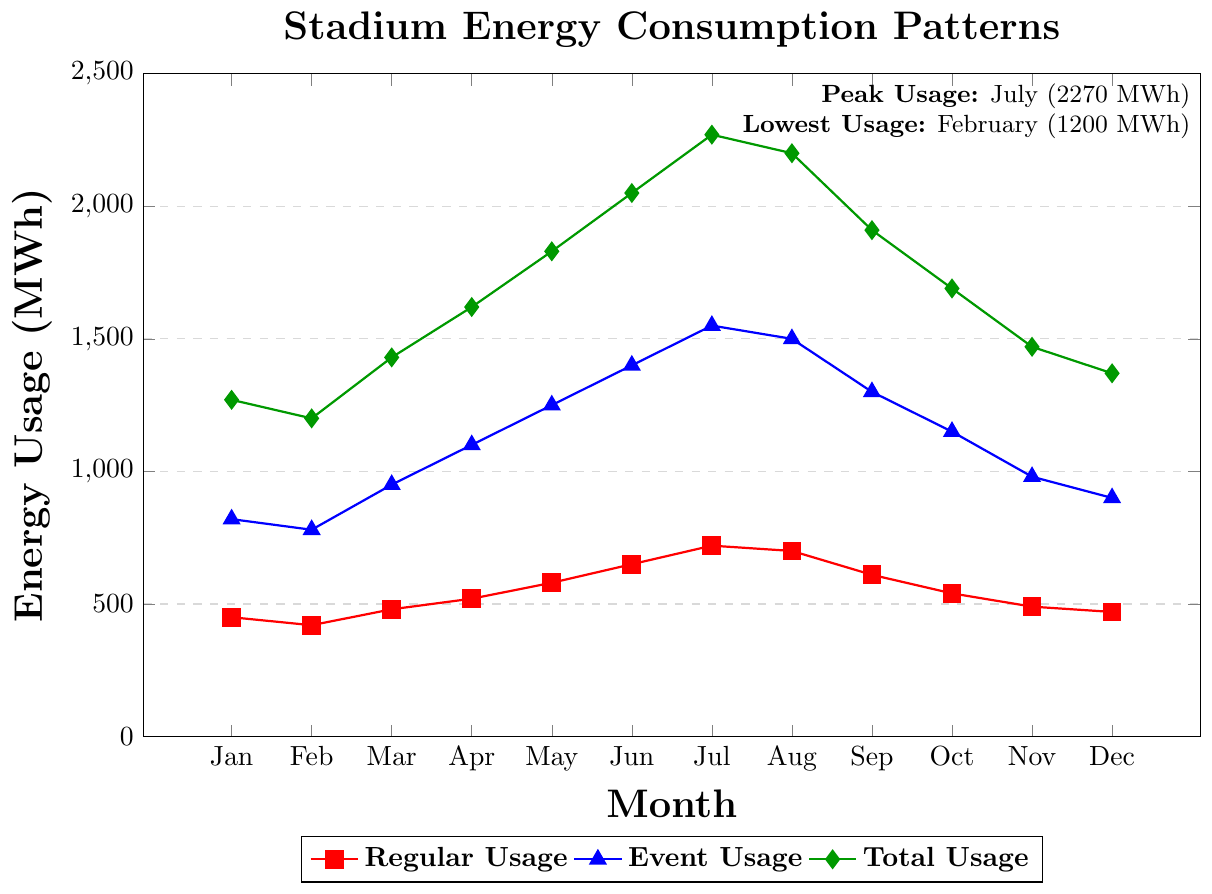What month has the highest total energy usage, and what is the value? The highest total energy usage is visually identified from the green line representing total usage. It peaks in July at 2270 MWh, as highlighted in the figure.
Answer: July, 2270 MWh Which month has the lowest regular usage and what is the value? The lowest regular usage is visually identified from the red line representing regular usage. It is lowest in February at 420 MWh.
Answer: February, 420 MWh How much more energy is used in events in April compared to March? The event usage for April and March can be read from the blue line. April is at 1100 MWh and March is at 950 MWh. Subtract March from April: 1100 - 950.
Answer: 150 MWh What is the total energy usage (MWh) in the first quarter (January, February, March)? Sum the total usage values for January, February, and March from the green line: 1270 (January) + 1200 (February) + 1430 (March).
Answer: 3900 MWh In which month is the difference between event usage and regular usage the greatest, and what is the difference? Identify months where the difference between blue (event usage) and red (regular usage) is the greatest. In April: 1100 (event) - 520 (regular) = 580 MWh. In July: 1550 (event) - 720 (regular) = 830 MWh. The greatest difference is in July.
Answer: July, 830 MWh How much does the total usage increase from the lowest to the highest month? Find the total usage of the lowest month (February: 1200 MWh) and the highest (July: 2270 MWh) and calculate the difference: 2270 - 1200.
Answer: 1070 MWh Compare the average regular usage in the first half (January to June) to the second half (July to December). Calculate the average regular usage for January to June: (450 + 420 + 480 + 520 + 580 + 650) / 6 = 516.67 MWh. Calculate for July to December: (720 + 700 + 610 + 540 + 490 + 470) / 6 = 588.33 MWh.
Answer: 516.67 MWh vs 588.33 MWh Which month sees the largest drop in total usage from the previous month? Check the green line for the largest drop between consecutive months. Compare, e.g., August to September: 2200 - 1910 = 290 MWh.
Answer: September, 290 MWh 